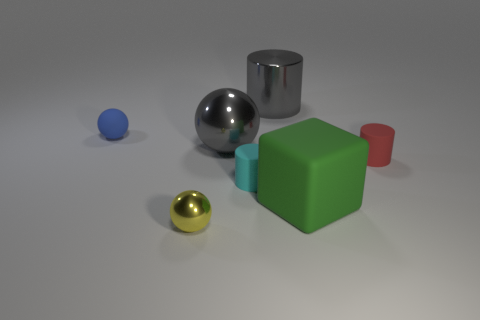Add 1 big cylinders. How many objects exist? 8 Subtract all cylinders. How many objects are left? 4 Add 2 small yellow things. How many small yellow things are left? 3 Add 2 small yellow metal things. How many small yellow metal things exist? 3 Subtract 1 yellow spheres. How many objects are left? 6 Subtract all yellow metal blocks. Subtract all big gray shiny cylinders. How many objects are left? 6 